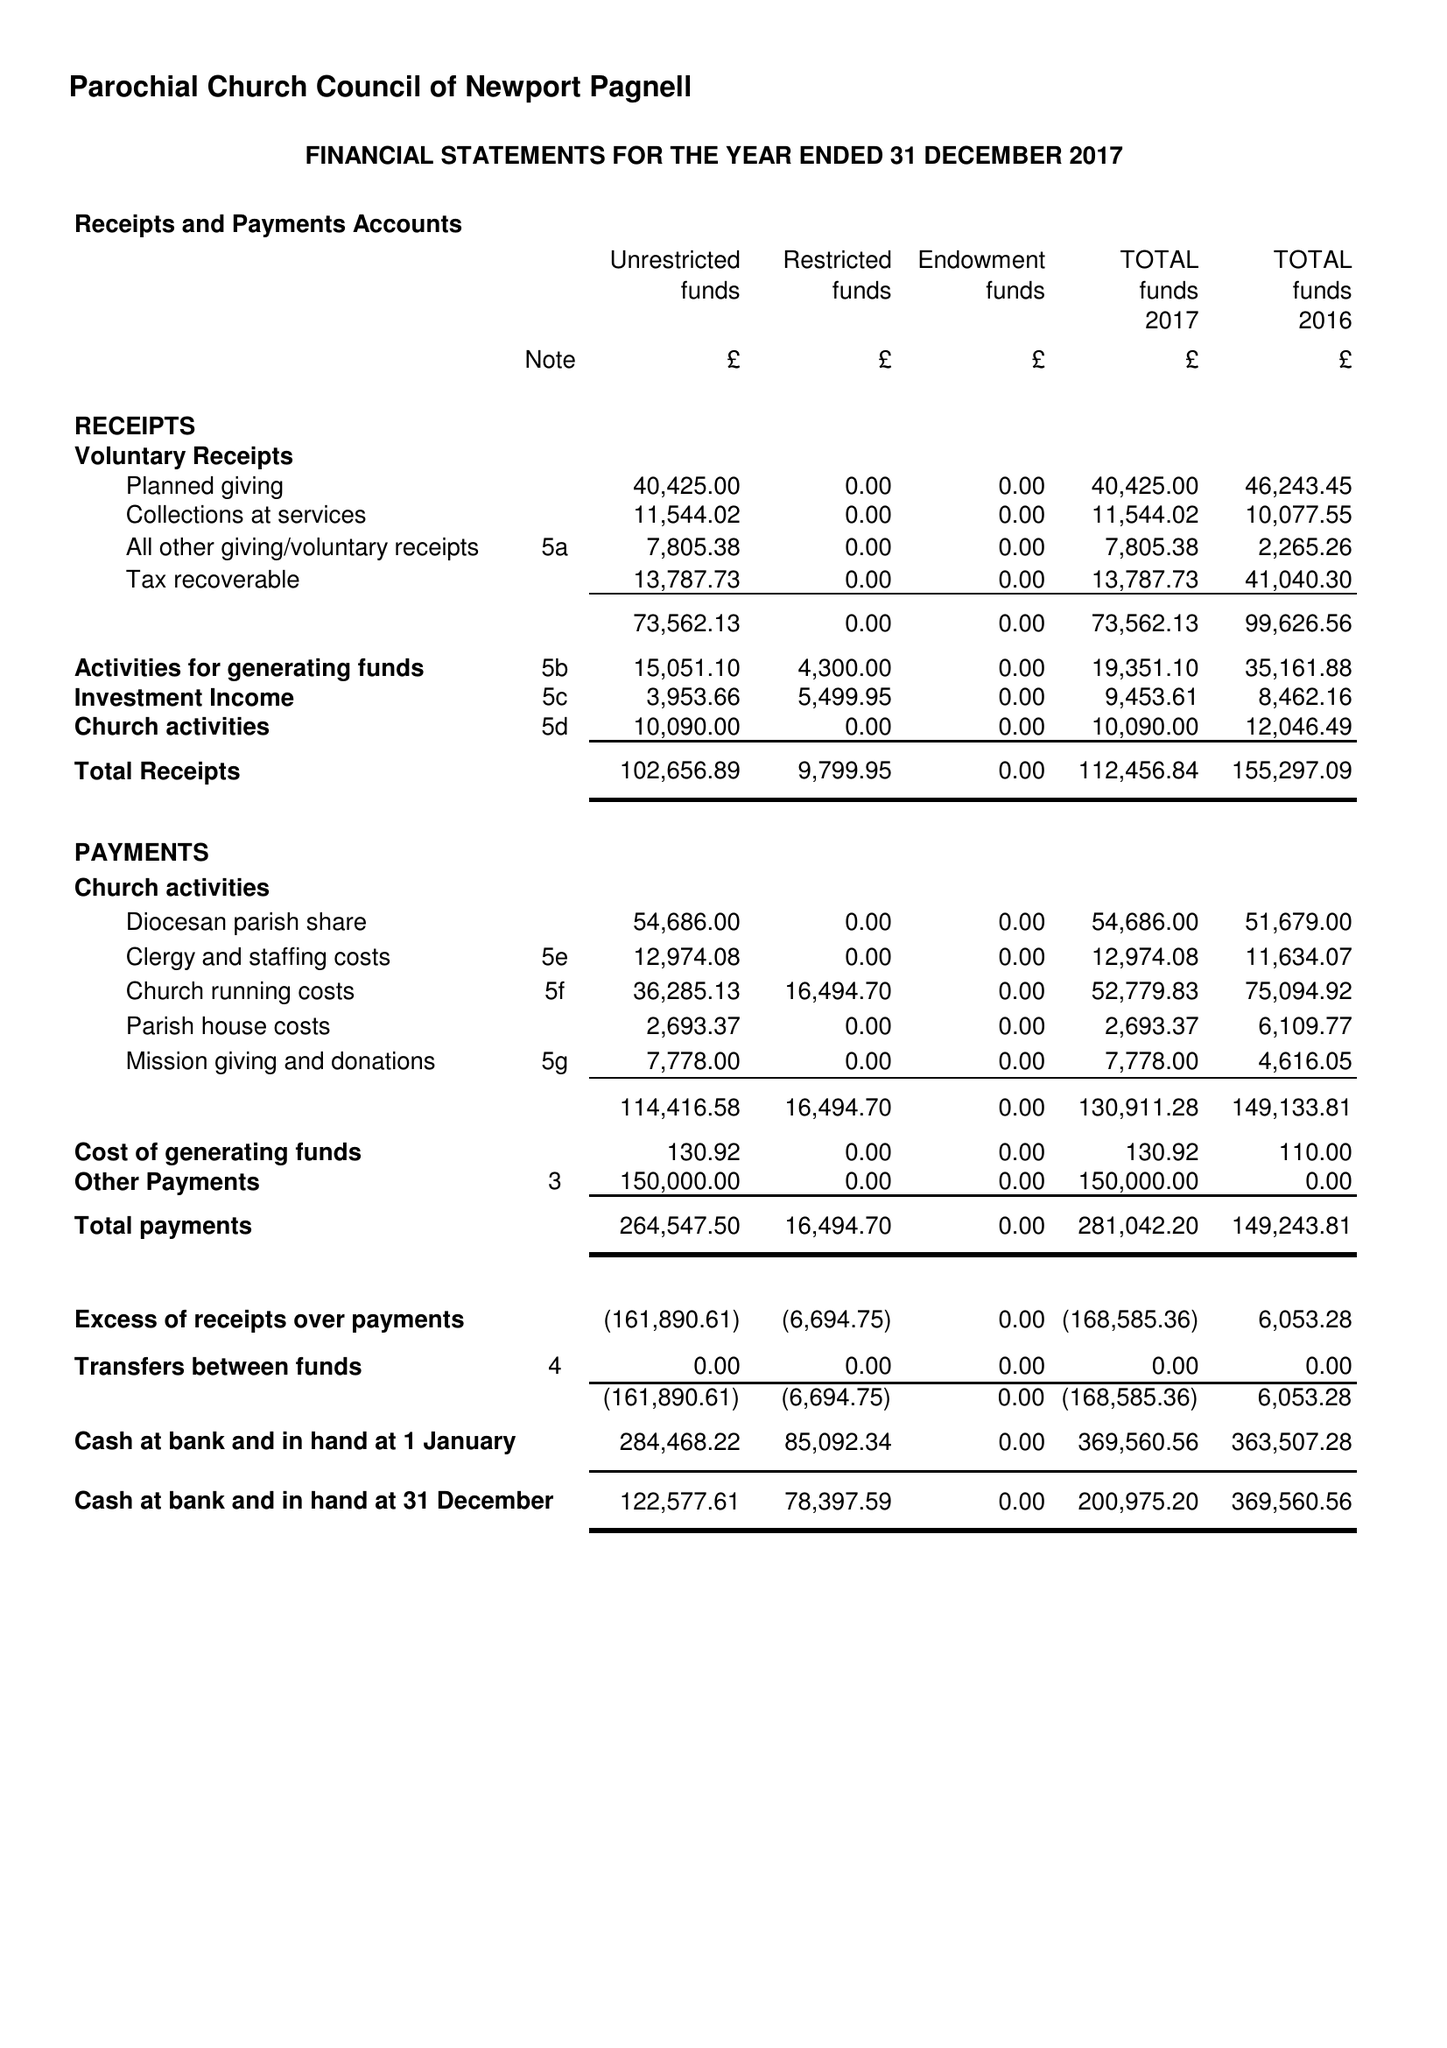What is the value for the spending_annually_in_british_pounds?
Answer the question using a single word or phrase. 281042.20 